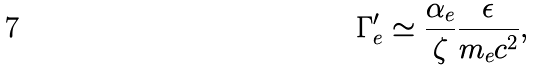Convert formula to latex. <formula><loc_0><loc_0><loc_500><loc_500>\Gamma ^ { \prime } _ { e } \simeq \frac { \alpha _ { e } } { \zeta } \frac { \epsilon } { m _ { e } c ^ { 2 } } ,</formula> 